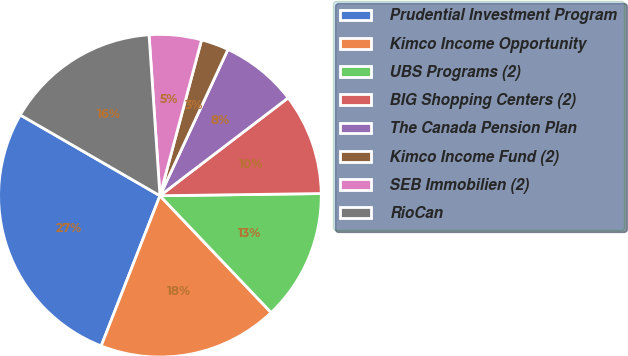Convert chart to OTSL. <chart><loc_0><loc_0><loc_500><loc_500><pie_chart><fcel>Prudential Investment Program<fcel>Kimco Income Opportunity<fcel>UBS Programs (2)<fcel>BIG Shopping Centers (2)<fcel>The Canada Pension Plan<fcel>Kimco Income Fund (2)<fcel>SEB Immobilien (2)<fcel>RioCan<nl><fcel>27.41%<fcel>18.04%<fcel>13.11%<fcel>10.16%<fcel>7.7%<fcel>2.77%<fcel>5.23%<fcel>15.58%<nl></chart> 